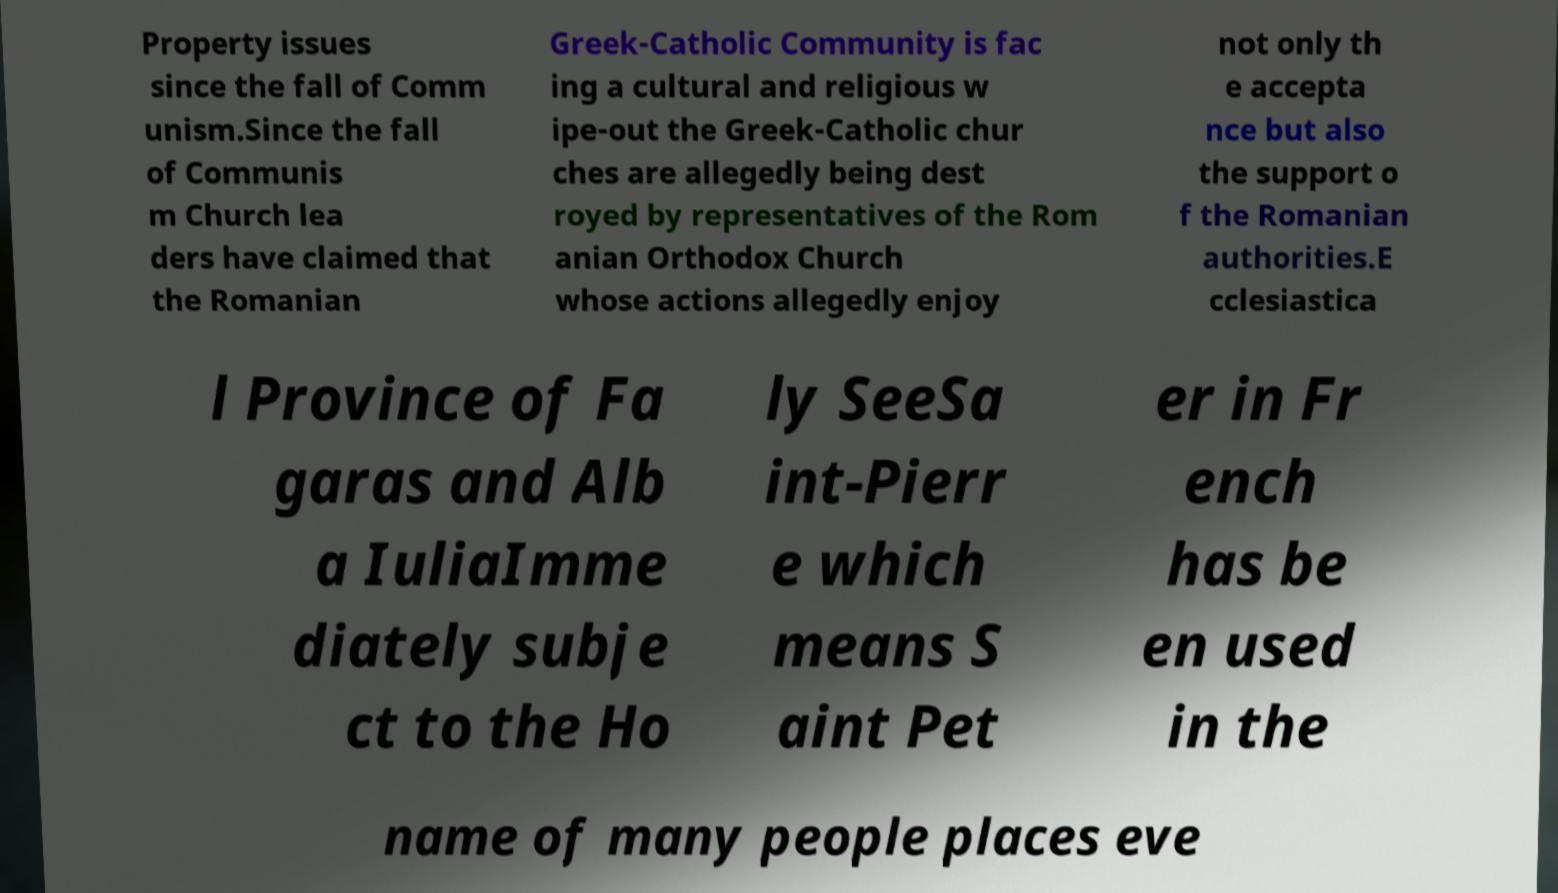Could you extract and type out the text from this image? Property issues since the fall of Comm unism.Since the fall of Communis m Church lea ders have claimed that the Romanian Greek-Catholic Community is fac ing a cultural and religious w ipe-out the Greek-Catholic chur ches are allegedly being dest royed by representatives of the Rom anian Orthodox Church whose actions allegedly enjoy not only th e accepta nce but also the support o f the Romanian authorities.E cclesiastica l Province of Fa garas and Alb a IuliaImme diately subje ct to the Ho ly SeeSa int-Pierr e which means S aint Pet er in Fr ench has be en used in the name of many people places eve 